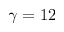Convert formula to latex. <formula><loc_0><loc_0><loc_500><loc_500>\gamma = 1 2</formula> 